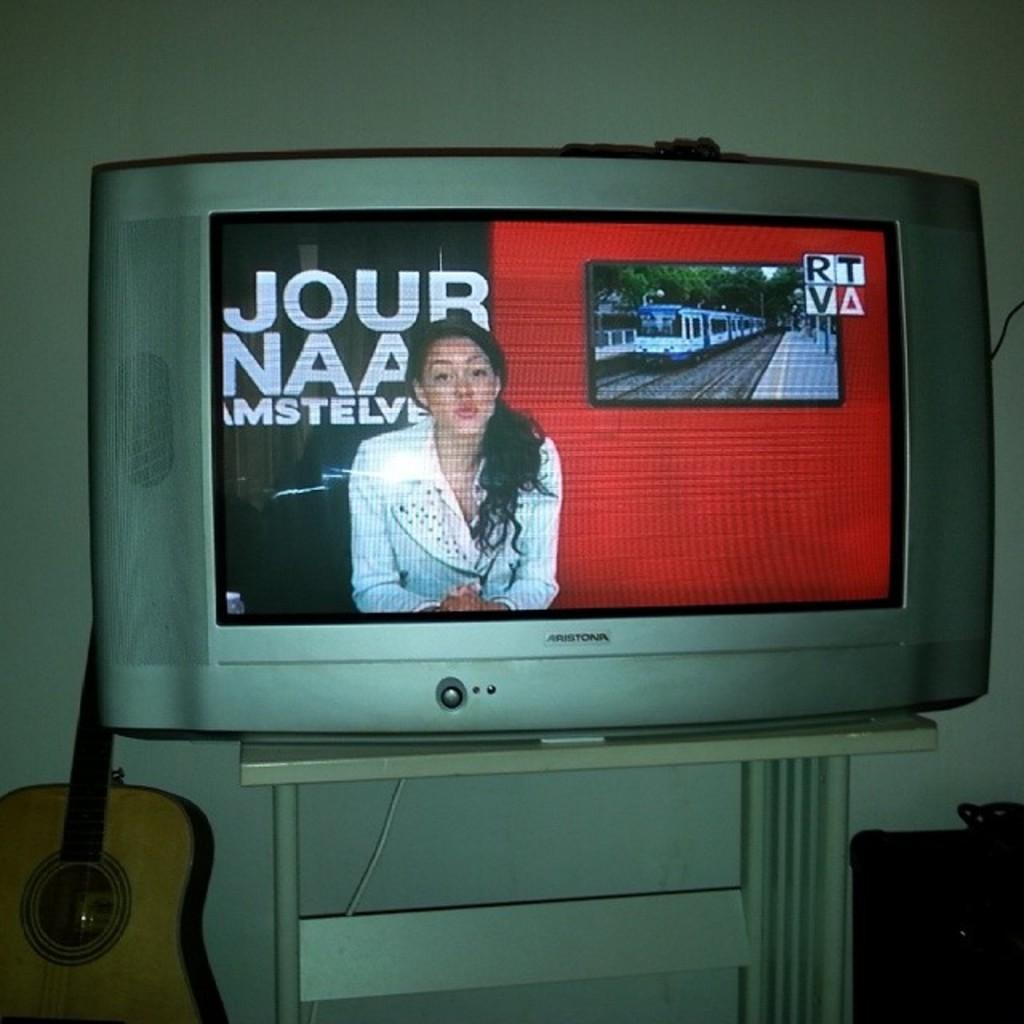Provide a one-sentence caption for the provided image. The TV next to a guitar has a female reporter in front of the words, 'Jour Naa Amstelve' on the screen. 